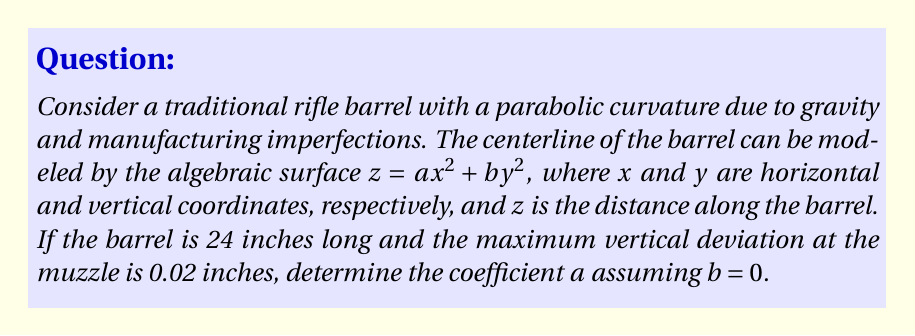What is the answer to this math problem? Let's approach this step-by-step:

1) The algebraic surface equation is given by:
   $z = ax^2 + by^2$

2) We're told that $b = 0$, so our equation simplifies to:
   $z = ax^2$

3) We know two points on this curve:
   - At the breech (start of the barrel): $(0, 0)$
   - At the muzzle (end of the barrel): $(24, 0.02)$

4) Let's use the muzzle point to solve for $a$:
   $0.02 = a(24)^2$

5) Simplify:
   $0.02 = 576a$

6) Solve for $a$:
   $a = \frac{0.02}{576} = \frac{1}{28800}$

7) To verify, we can check the midpoint of the barrel:
   At $x = 12$: $z = \frac{1}{28800}(12)^2 = 0.005$ inches

   This shows that the deviation at the midpoint is one-quarter of the deviation at the muzzle, which is consistent with a parabolic curve.
Answer: $a = \frac{1}{28800}$ 